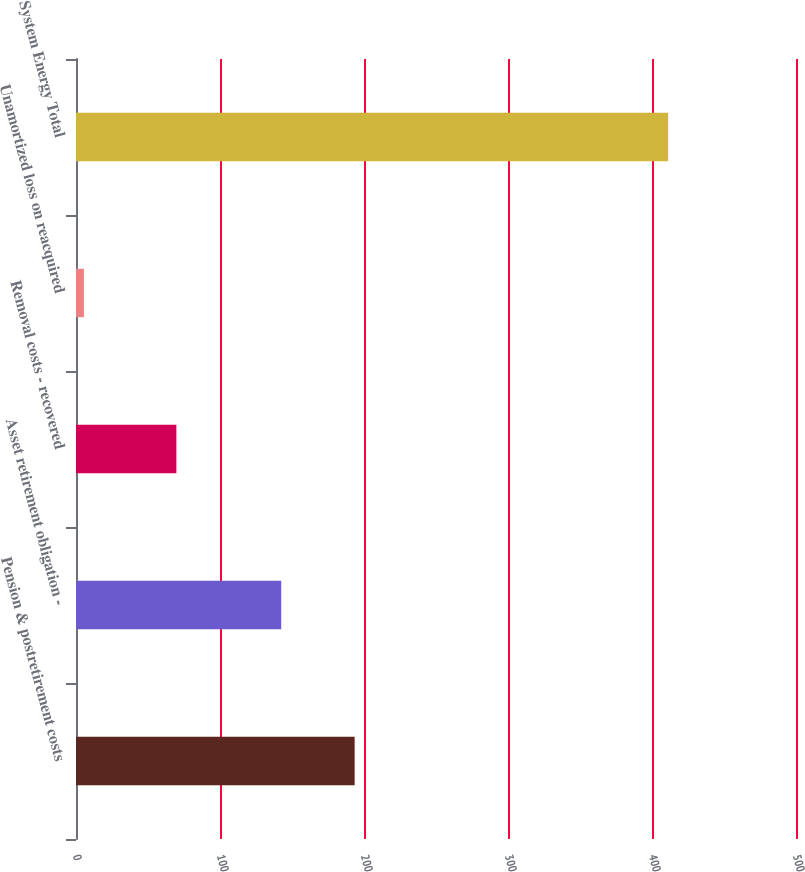Convert chart. <chart><loc_0><loc_0><loc_500><loc_500><bar_chart><fcel>Pension & postretirement costs<fcel>Asset retirement obligation -<fcel>Removal costs - recovered<fcel>Unamortized loss on reacquired<fcel>System Energy Total<nl><fcel>193.5<fcel>142.5<fcel>69.7<fcel>5.5<fcel>411.2<nl></chart> 